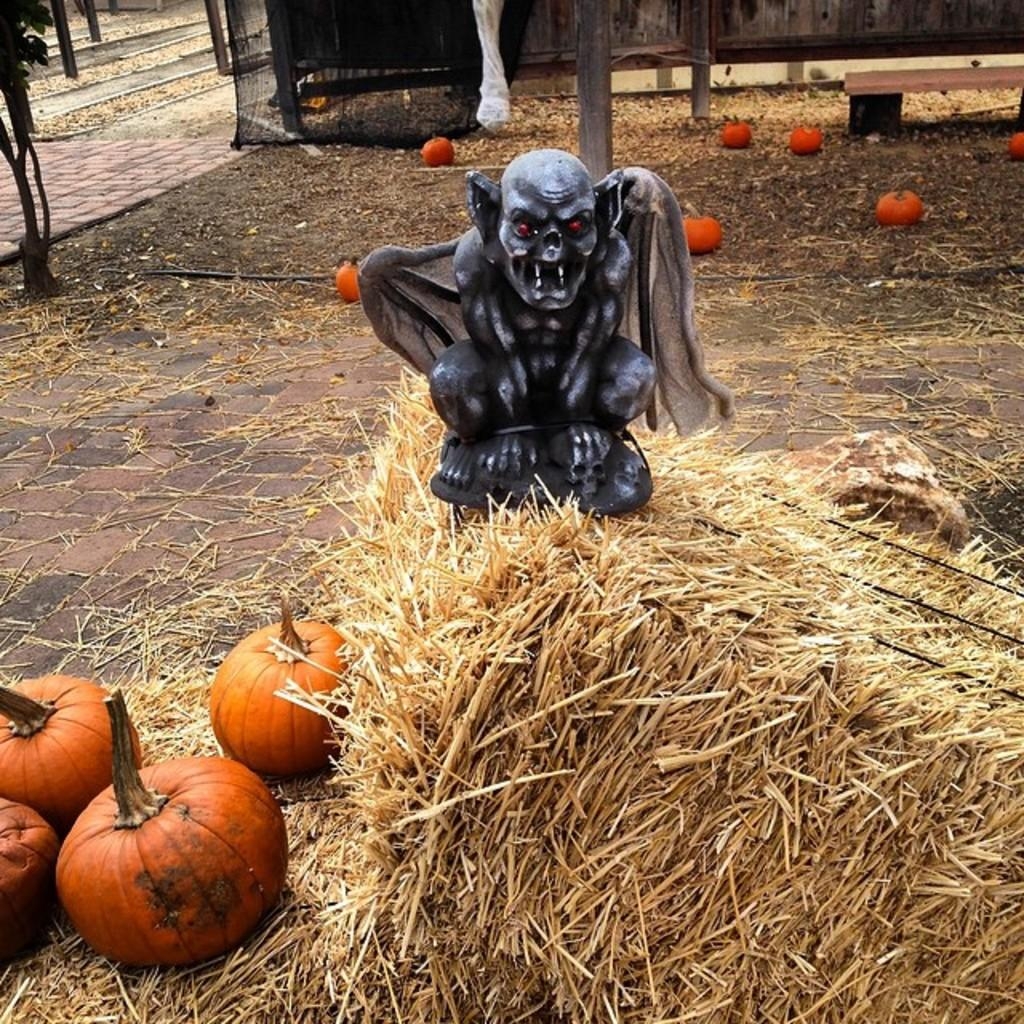What is the main subject in the image? There is a statue in the image. What is the statue standing on? The statue is on dry grass. What other objects are present around the statue? There are pumpkins around the statue. Where is the desk located in the image? There is no desk present in the image. What type of rings can be seen on the statue's fingers? The statue does not have fingers or rings; it is a non-human subject. 